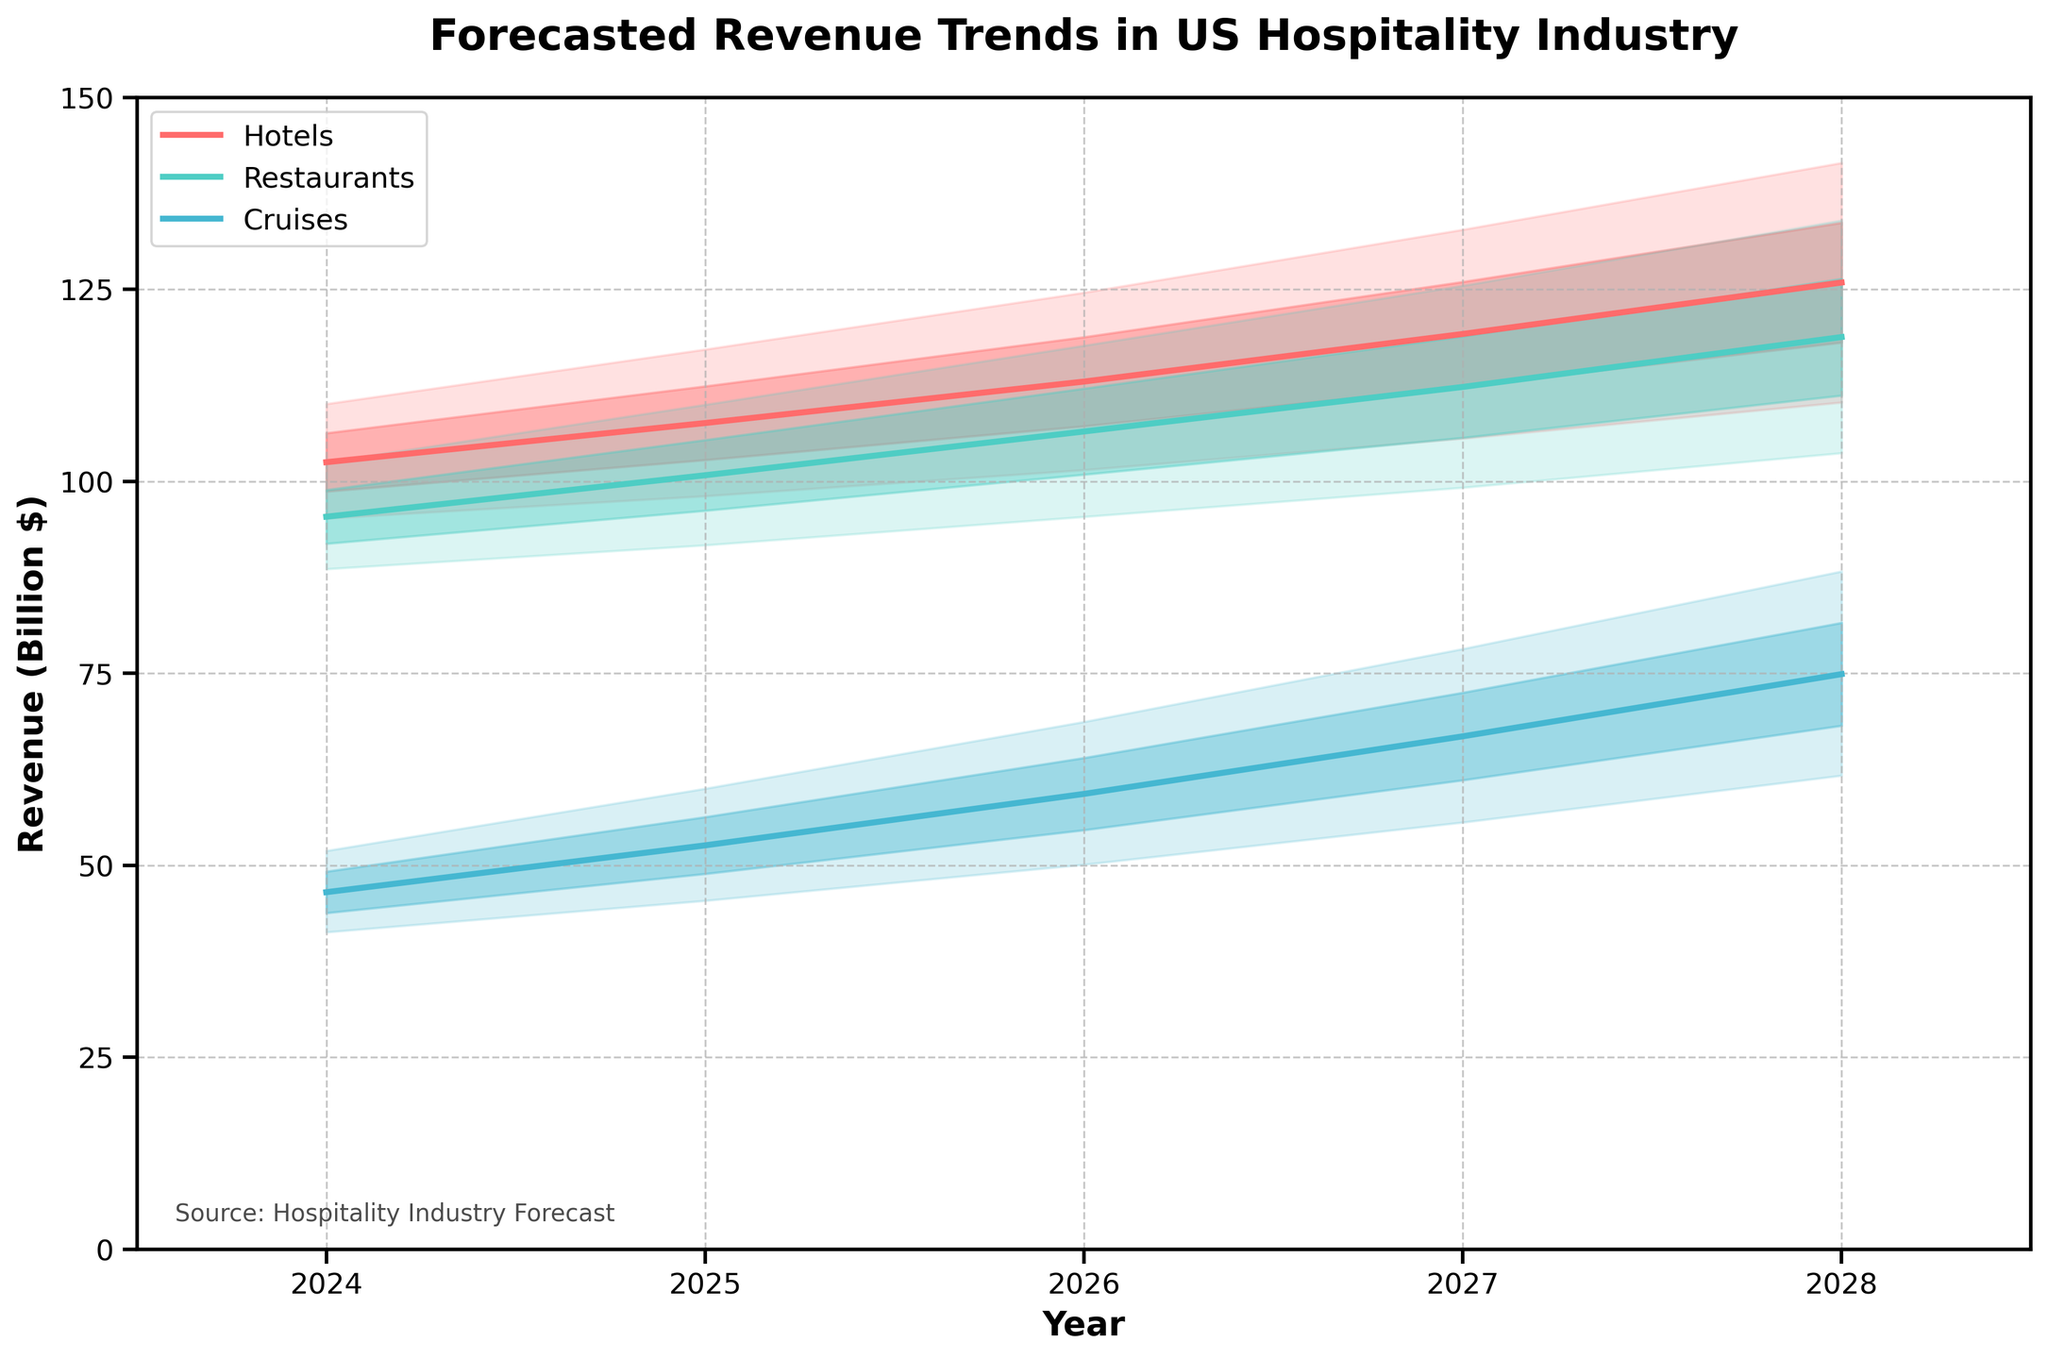What is the title of the chart? The title of the chart is displayed at the top center of the figure. The title reads "Forecasted Revenue Trends in US Hospitality Industry".
Answer: Forecasted Revenue Trends in US Hospitality Industry What is the forecasted revenue range for hotels in 2024? According to the chart, for the year 2024, the forecasted revenue range for hotels is represented by the shaded area between the "Low" and "High" lines. For hotels in 2024, the "Low" value is 95.2 and the "High" value is 110.1.
Answer: 95.2 to 110.1 billion $ Which segment has the highest median forecasted revenue in 2026? The median forecasted revenue is represented by the "Mid" line, which is plotted for each segment. In 2026, hotels have a "Mid" value of 113.0 billion $, restaurants have 106.5 billion $, and cruises have 59.3 billion $.
Answer: Hotels What is the difference between the highest forecasted revenue for restaurants and cruises in 2025? To find the difference, subtract the "High" value for cruises from the "High" value for restaurants in 2025. These values are 110.0 billion $ (restaurants) and 60.0 billion $ (cruises), respectively. So, the difference is 110.0 - 60.0.
Answer: 50.0 billion $ Which segment shows the largest increase in median forecasted revenue from 2024 to 2028? To determine the segment with the largest increase, subtract the 2024 "Mid" value from the 2028 "Mid" value for each segment. The differences are as follows: Hotels: 125.9 - 102.5 = 23.4 billion $, Restaurants: 118.8 - 95.4 = 23.4 billion $, Cruises: 74.9 - 46.5 = 28.4 billion $. Cruises have the largest increase.
Answer: Cruises What is the forecasted revenue range for cruises in 2027? According to the chart, for the year 2027, the forecasted revenue range for cruises is represented by the shaded area between the "Low" and "High" lines. For cruises in 2027, the "Low" value is 55.6 and the "High" value is 78.2.
Answer: 55.6 to 78.2 billion $ In which year is the median forecasted revenue for restaurants closest to 100 billion $? Examine the "Mid" line values for restaurants across the different years. In 2024: 95.4 billion $, 2025: 100.8 billion $, 2026: 106.5 billion $, 2027: 112.3 billion $, 2028: 118.8 billion $ . The value closest to 100 billion $ is in 2025.
Answer: 2025 Is the forecasted revenue for hotels increasing or decreasing over the years, and by how much from the first to the last year? The median forecasted revenue for hotels shows an increasing trend. Subtract the "Mid" value of 2024 from the "Mid" value of 2028. The initial value in 2024 is 102.5 billion $ and the final value in 2028 is 125.9 billion $. The increase is 125.9 - 102.5.
Answer: Increasing by 23.4 billion $ Which segment has the smallest forecasted revenue range in 2026? Calculate the range for each segment by subtracting the "Low" value from the "High" value for the year 2026. Hotels: 124.6 - 101.5 = 23.1 billion $, Restaurants: 117.7 - 95.4 = 22.3 billion $, Cruises: 68.7 - 50.1 = 18.6 billion $. The smallest range is for cruises at 18.6 billion $.
Answer: Cruises Which year shows the largest forecasted range for hotel revenue? Calculate the range for hotel revenue for each year by subtracting the "Low" value from the "High" value for each year. 2024: 110.1 - 95.2 = 14.9 billion $, 2025: 117.2 - 98.1 = 19.1 billion $, 2026: 124.6 - 101.5 = 23.1 billion $, 2027: 132.8 - 105.6 = 27.2 billion $, 2028: 141.5 - 110.3 = 31.2 billion $. The largest range occurs in 2028.
Answer: 2028 